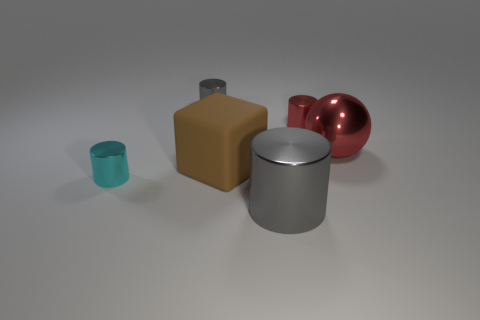Can you describe the shapes and colors of the objects presented? Certainly! There are five distinct objects varying in both shape and color. The first is a golden brown cube, followed by a small teal cylinder. Next is a reflective, dark gray cube, then a larger, shiny silver cylinder, and finally, a glossy red sphere. Each object boasts a smooth surface and seems to be rendered graphically to showcase different geometric forms and reflectivity. Which object stands out the most to you and why? The glossy red sphere stands out due to its vibrant color and the way it contrasts with the other objects in both shape and hue. Its reflective surface catches the light in a way that draws the eye, making it a focal point against the more muted tones of the other objects. 